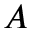Convert formula to latex. <formula><loc_0><loc_0><loc_500><loc_500>A</formula> 